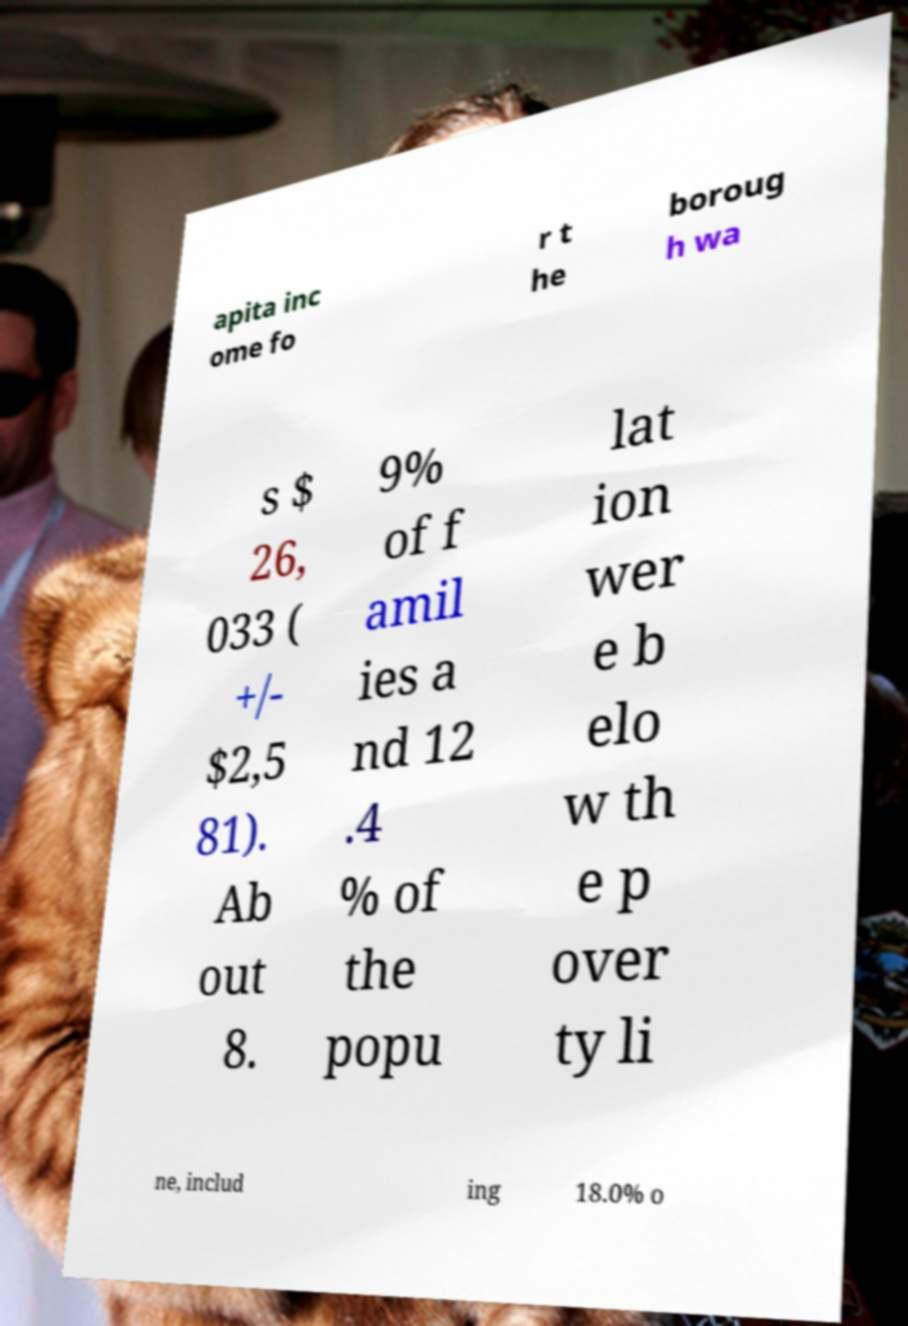Please read and relay the text visible in this image. What does it say? apita inc ome fo r t he boroug h wa s $ 26, 033 ( +/- $2,5 81). Ab out 8. 9% of f amil ies a nd 12 .4 % of the popu lat ion wer e b elo w th e p over ty li ne, includ ing 18.0% o 